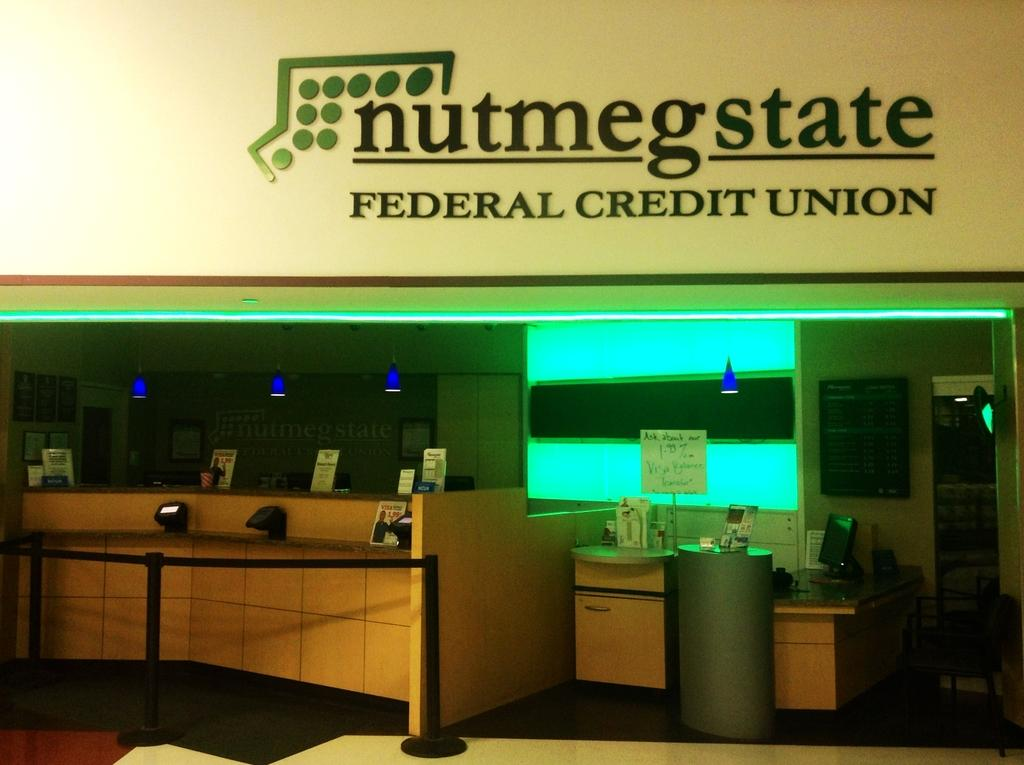Provide a one-sentence caption for the provided image. The office shown is that of the Federal Credit Union. 